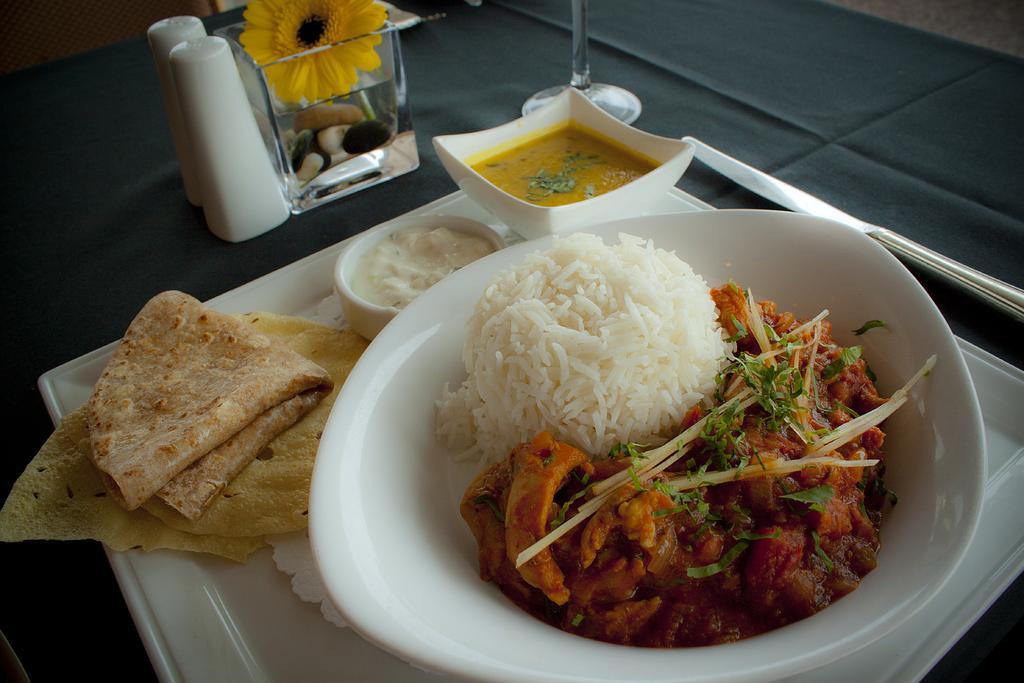How would you summarize this image in a sentence or two? In this image we can see food in a bowl placed in a tray. At the top of the image we can see flower vase and tumbler. 